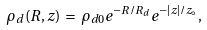<formula> <loc_0><loc_0><loc_500><loc_500>\rho _ { d } ( R , z ) \, = \, \rho _ { d 0 } e ^ { - R / R _ { d } } e ^ { - { | z | } / z _ { \circ } } ,</formula> 